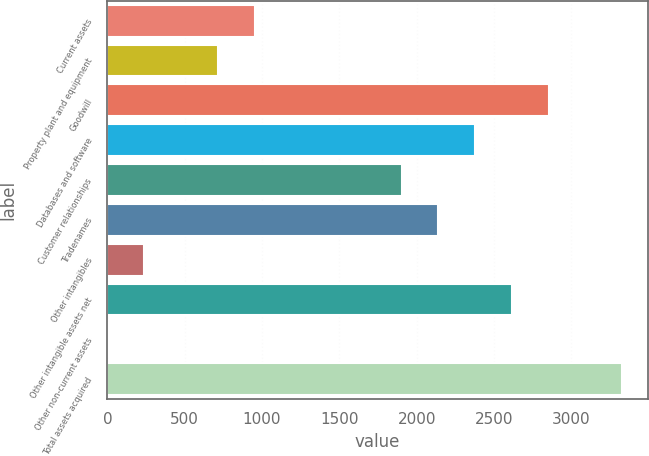Convert chart to OTSL. <chart><loc_0><loc_0><loc_500><loc_500><bar_chart><fcel>Current assets<fcel>Property plant and equipment<fcel>Goodwill<fcel>Databases and software<fcel>Customer relationships<fcel>Tradenames<fcel>Other intangibles<fcel>Other intangible assets net<fcel>Other non-current assets<fcel>Total assets acquired<nl><fcel>951.8<fcel>714.1<fcel>2853.4<fcel>2378<fcel>1902.6<fcel>2140.3<fcel>238.7<fcel>2615.7<fcel>1<fcel>3328.8<nl></chart> 